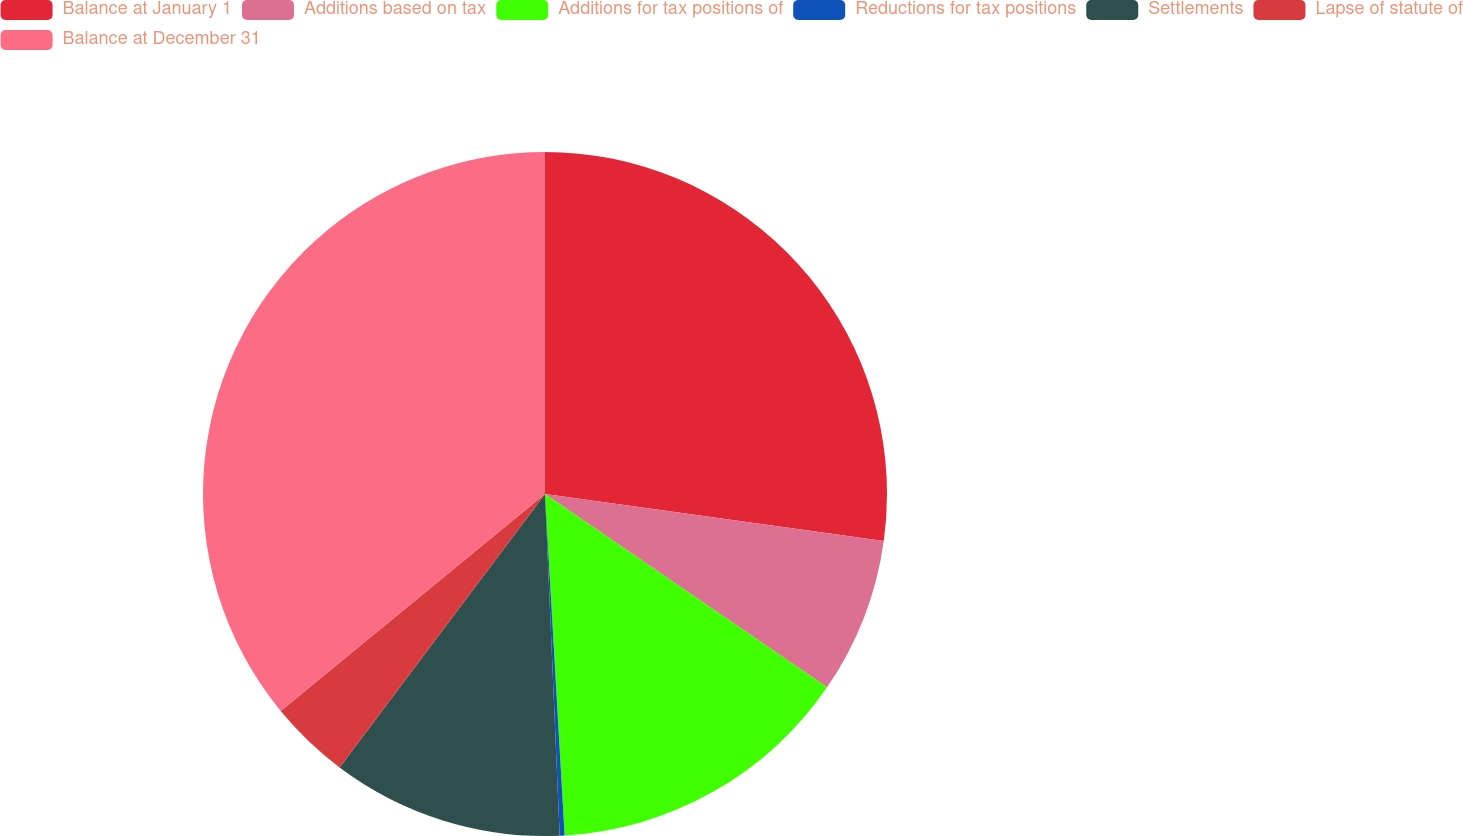Convert chart. <chart><loc_0><loc_0><loc_500><loc_500><pie_chart><fcel>Balance at January 1<fcel>Additions based on tax<fcel>Additions for tax positions of<fcel>Reductions for tax positions<fcel>Settlements<fcel>Lapse of statute of<fcel>Balance at December 31<nl><fcel>27.19%<fcel>7.37%<fcel>14.52%<fcel>0.23%<fcel>10.94%<fcel>3.8%<fcel>35.94%<nl></chart> 